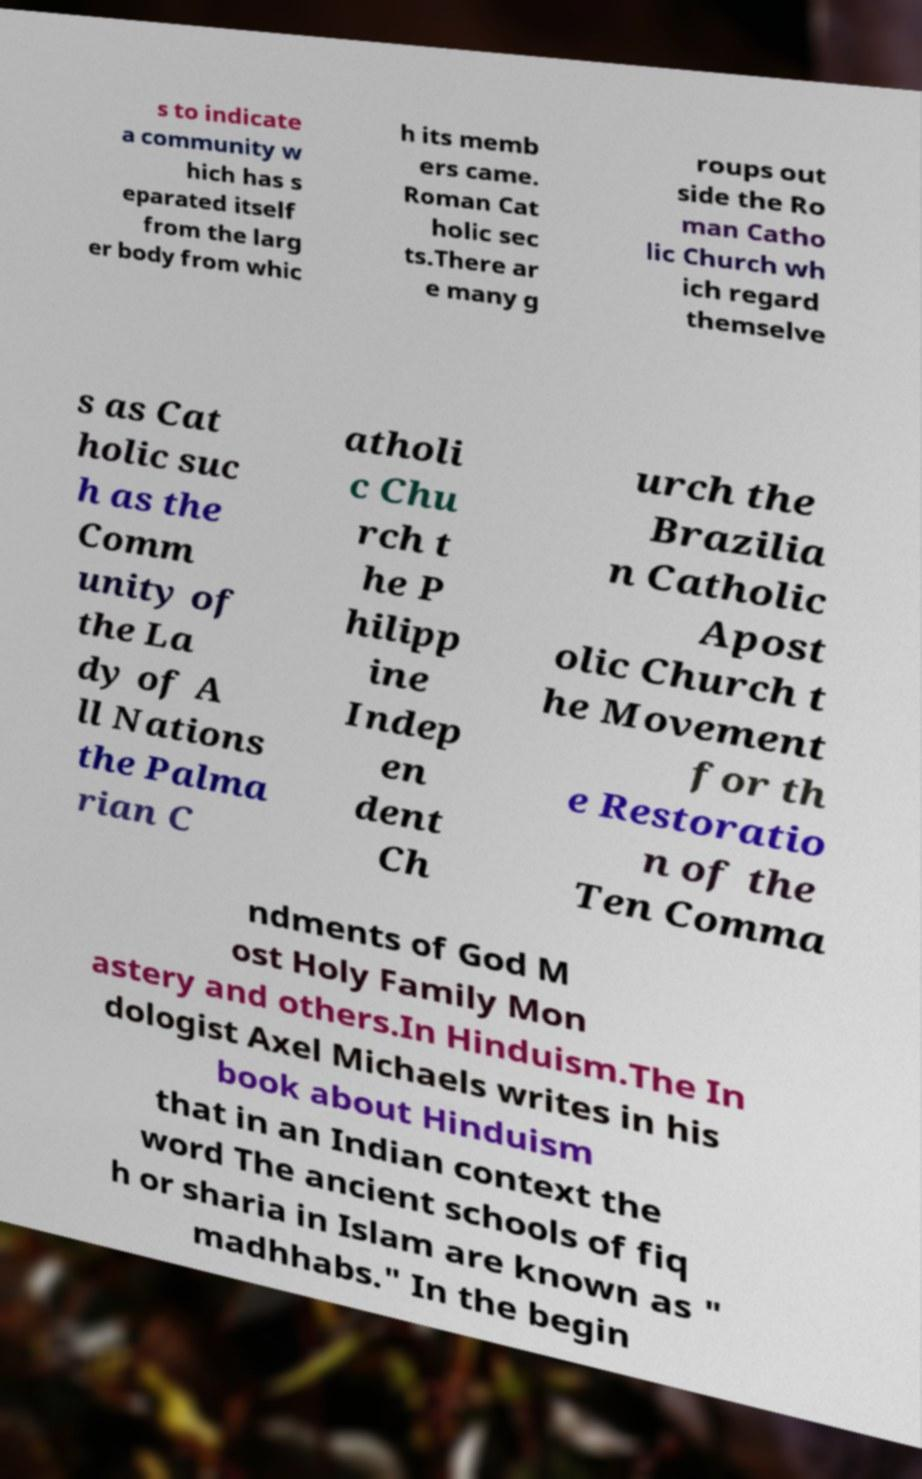Can you read and provide the text displayed in the image?This photo seems to have some interesting text. Can you extract and type it out for me? s to indicate a community w hich has s eparated itself from the larg er body from whic h its memb ers came. Roman Cat holic sec ts.There ar e many g roups out side the Ro man Catho lic Church wh ich regard themselve s as Cat holic suc h as the Comm unity of the La dy of A ll Nations the Palma rian C atholi c Chu rch t he P hilipp ine Indep en dent Ch urch the Brazilia n Catholic Apost olic Church t he Movement for th e Restoratio n of the Ten Comma ndments of God M ost Holy Family Mon astery and others.In Hinduism.The In dologist Axel Michaels writes in his book about Hinduism that in an Indian context the word The ancient schools of fiq h or sharia in Islam are known as " madhhabs." In the begin 